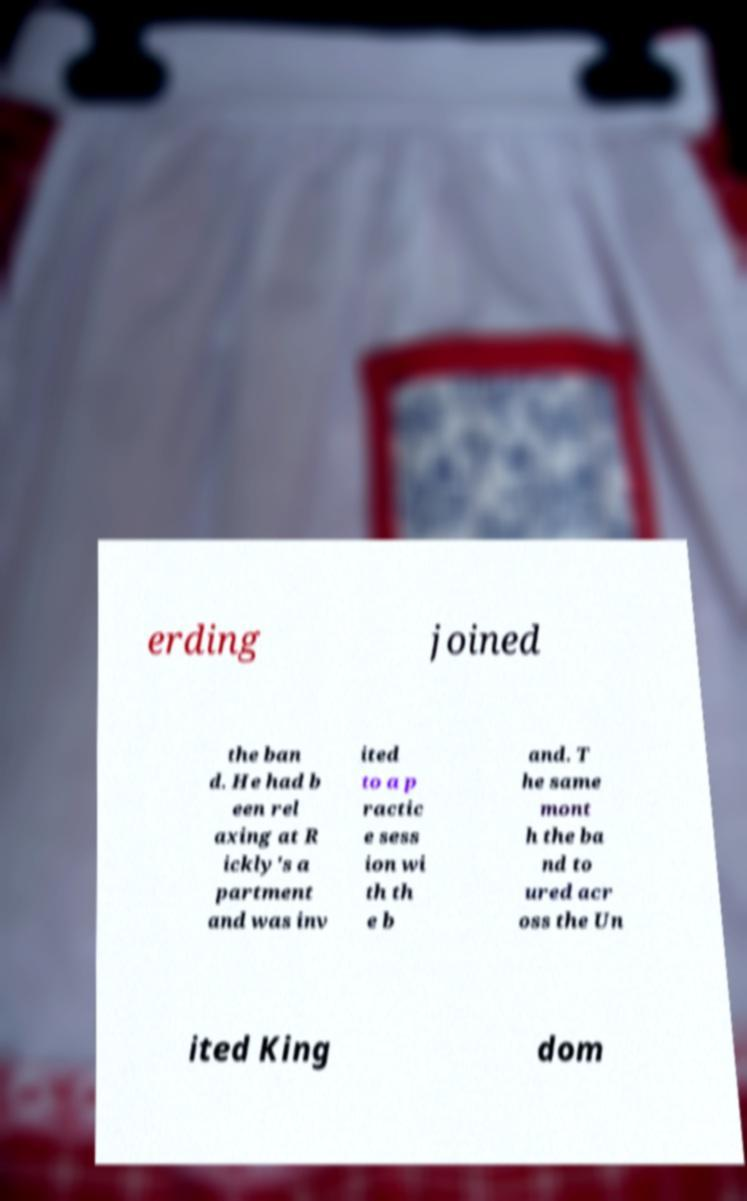I need the written content from this picture converted into text. Can you do that? erding joined the ban d. He had b een rel axing at R ickly's a partment and was inv ited to a p ractic e sess ion wi th th e b and. T he same mont h the ba nd to ured acr oss the Un ited King dom 